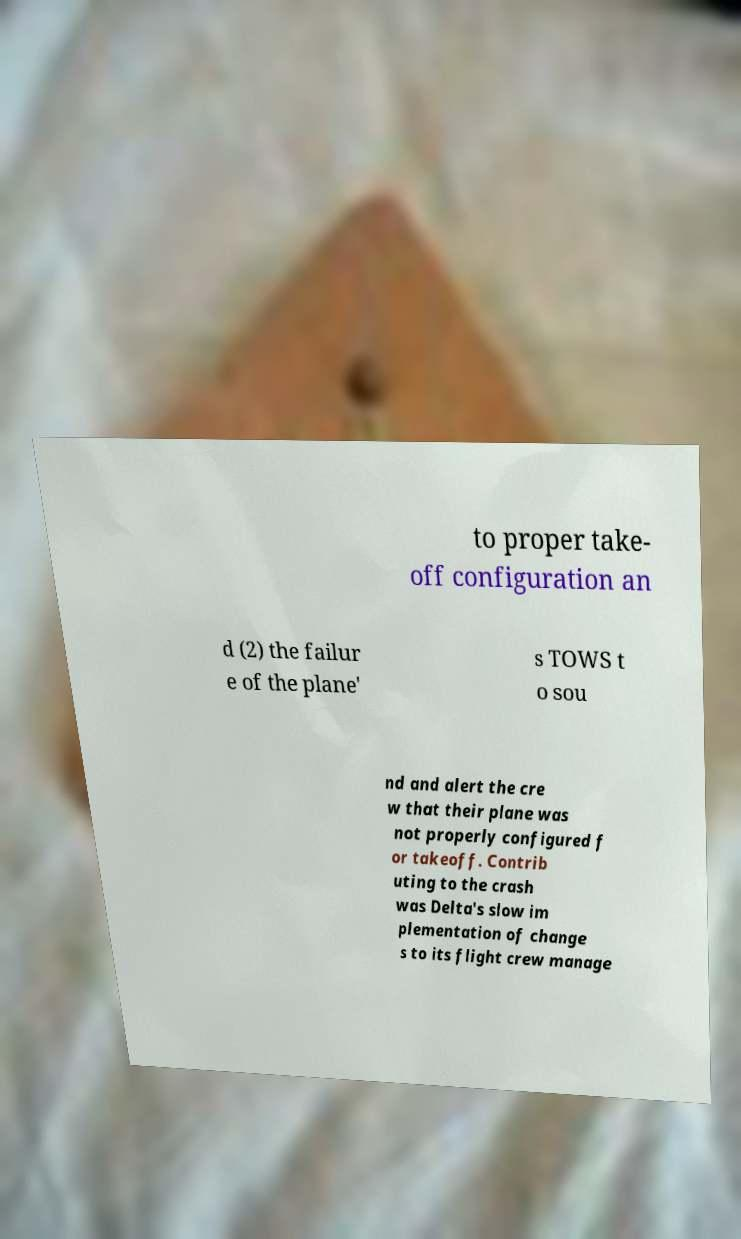Can you accurately transcribe the text from the provided image for me? to proper take- off configuration an d (2) the failur e of the plane' s TOWS t o sou nd and alert the cre w that their plane was not properly configured f or takeoff. Contrib uting to the crash was Delta's slow im plementation of change s to its flight crew manage 